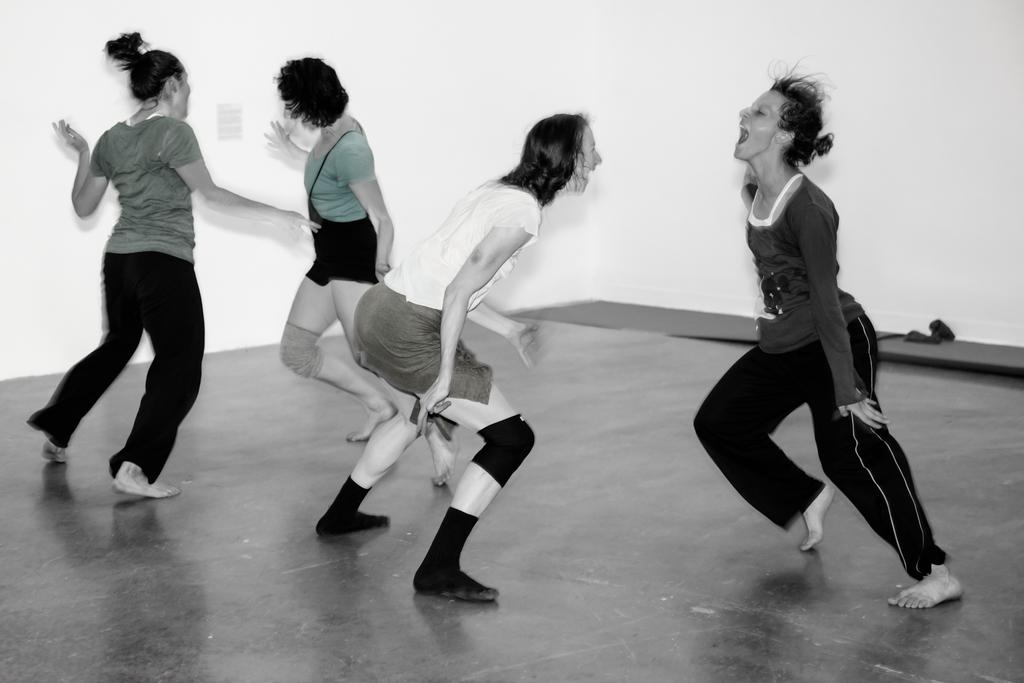What is at the bottom of the image? There is a floor at the bottom of the image. Who or what is in the foreground of the image? There are people in the foreground of the image. What can be seen in the right corner of the image? There is an object in the right corner of the image. What color is the background of the image? The background of the image is white. What type of toy is being used to trick the people in the image? There is no toy or trickery present in the image; it simply shows people and an object in a white background. 